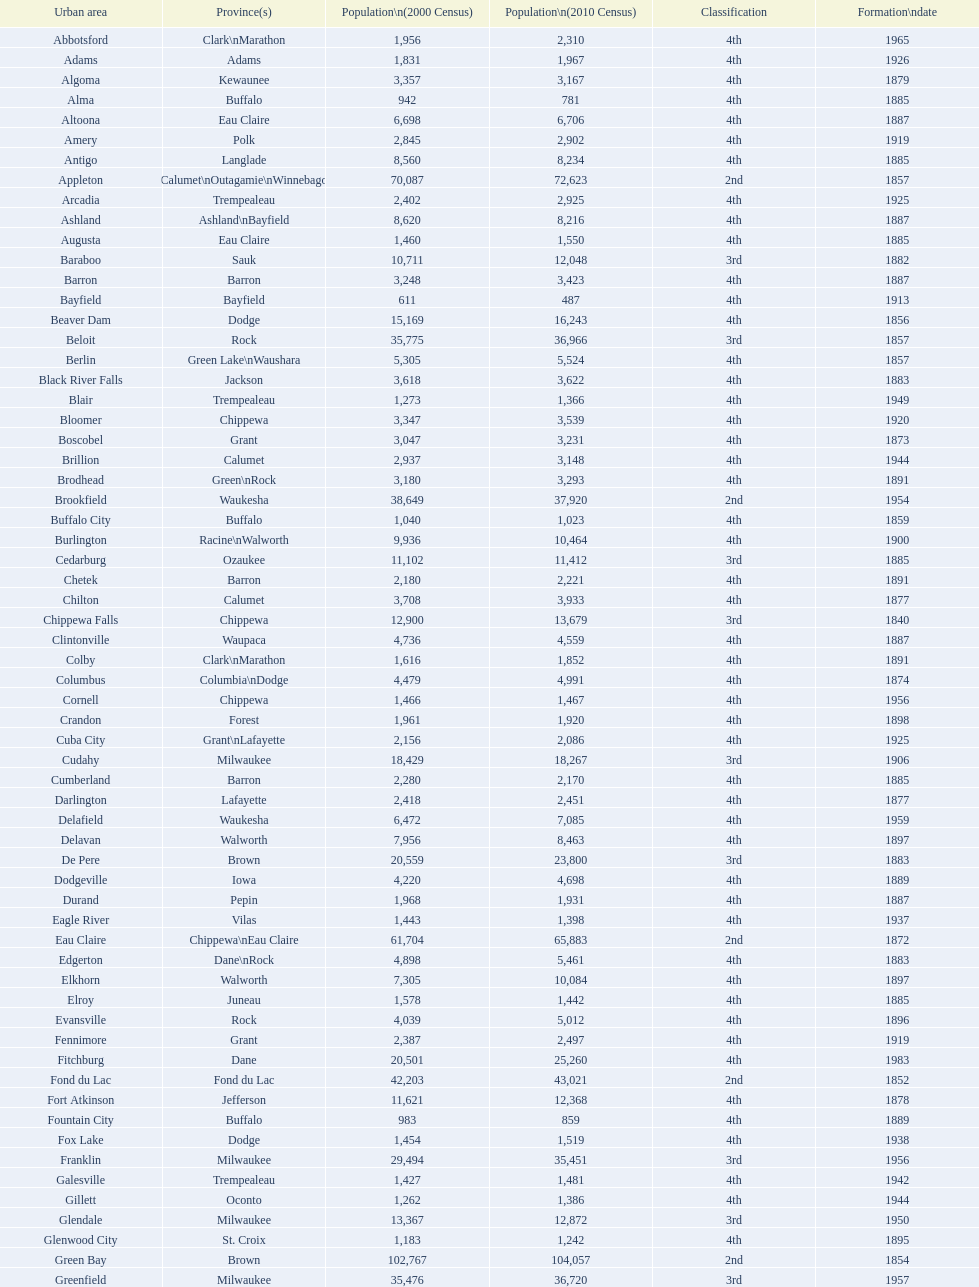Could you parse the entire table as a dict? {'header': ['Urban area', 'Province(s)', 'Population\\n(2000 Census)', 'Population\\n(2010 Census)', 'Classification', 'Formation\\ndate'], 'rows': [['Abbotsford', 'Clark\\nMarathon', '1,956', '2,310', '4th', '1965'], ['Adams', 'Adams', '1,831', '1,967', '4th', '1926'], ['Algoma', 'Kewaunee', '3,357', '3,167', '4th', '1879'], ['Alma', 'Buffalo', '942', '781', '4th', '1885'], ['Altoona', 'Eau Claire', '6,698', '6,706', '4th', '1887'], ['Amery', 'Polk', '2,845', '2,902', '4th', '1919'], ['Antigo', 'Langlade', '8,560', '8,234', '4th', '1885'], ['Appleton', 'Calumet\\nOutagamie\\nWinnebago', '70,087', '72,623', '2nd', '1857'], ['Arcadia', 'Trempealeau', '2,402', '2,925', '4th', '1925'], ['Ashland', 'Ashland\\nBayfield', '8,620', '8,216', '4th', '1887'], ['Augusta', 'Eau Claire', '1,460', '1,550', '4th', '1885'], ['Baraboo', 'Sauk', '10,711', '12,048', '3rd', '1882'], ['Barron', 'Barron', '3,248', '3,423', '4th', '1887'], ['Bayfield', 'Bayfield', '611', '487', '4th', '1913'], ['Beaver Dam', 'Dodge', '15,169', '16,243', '4th', '1856'], ['Beloit', 'Rock', '35,775', '36,966', '3rd', '1857'], ['Berlin', 'Green Lake\\nWaushara', '5,305', '5,524', '4th', '1857'], ['Black River Falls', 'Jackson', '3,618', '3,622', '4th', '1883'], ['Blair', 'Trempealeau', '1,273', '1,366', '4th', '1949'], ['Bloomer', 'Chippewa', '3,347', '3,539', '4th', '1920'], ['Boscobel', 'Grant', '3,047', '3,231', '4th', '1873'], ['Brillion', 'Calumet', '2,937', '3,148', '4th', '1944'], ['Brodhead', 'Green\\nRock', '3,180', '3,293', '4th', '1891'], ['Brookfield', 'Waukesha', '38,649', '37,920', '2nd', '1954'], ['Buffalo City', 'Buffalo', '1,040', '1,023', '4th', '1859'], ['Burlington', 'Racine\\nWalworth', '9,936', '10,464', '4th', '1900'], ['Cedarburg', 'Ozaukee', '11,102', '11,412', '3rd', '1885'], ['Chetek', 'Barron', '2,180', '2,221', '4th', '1891'], ['Chilton', 'Calumet', '3,708', '3,933', '4th', '1877'], ['Chippewa Falls', 'Chippewa', '12,900', '13,679', '3rd', '1840'], ['Clintonville', 'Waupaca', '4,736', '4,559', '4th', '1887'], ['Colby', 'Clark\\nMarathon', '1,616', '1,852', '4th', '1891'], ['Columbus', 'Columbia\\nDodge', '4,479', '4,991', '4th', '1874'], ['Cornell', 'Chippewa', '1,466', '1,467', '4th', '1956'], ['Crandon', 'Forest', '1,961', '1,920', '4th', '1898'], ['Cuba City', 'Grant\\nLafayette', '2,156', '2,086', '4th', '1925'], ['Cudahy', 'Milwaukee', '18,429', '18,267', '3rd', '1906'], ['Cumberland', 'Barron', '2,280', '2,170', '4th', '1885'], ['Darlington', 'Lafayette', '2,418', '2,451', '4th', '1877'], ['Delafield', 'Waukesha', '6,472', '7,085', '4th', '1959'], ['Delavan', 'Walworth', '7,956', '8,463', '4th', '1897'], ['De Pere', 'Brown', '20,559', '23,800', '3rd', '1883'], ['Dodgeville', 'Iowa', '4,220', '4,698', '4th', '1889'], ['Durand', 'Pepin', '1,968', '1,931', '4th', '1887'], ['Eagle River', 'Vilas', '1,443', '1,398', '4th', '1937'], ['Eau Claire', 'Chippewa\\nEau Claire', '61,704', '65,883', '2nd', '1872'], ['Edgerton', 'Dane\\nRock', '4,898', '5,461', '4th', '1883'], ['Elkhorn', 'Walworth', '7,305', '10,084', '4th', '1897'], ['Elroy', 'Juneau', '1,578', '1,442', '4th', '1885'], ['Evansville', 'Rock', '4,039', '5,012', '4th', '1896'], ['Fennimore', 'Grant', '2,387', '2,497', '4th', '1919'], ['Fitchburg', 'Dane', '20,501', '25,260', '4th', '1983'], ['Fond du Lac', 'Fond du Lac', '42,203', '43,021', '2nd', '1852'], ['Fort Atkinson', 'Jefferson', '11,621', '12,368', '4th', '1878'], ['Fountain City', 'Buffalo', '983', '859', '4th', '1889'], ['Fox Lake', 'Dodge', '1,454', '1,519', '4th', '1938'], ['Franklin', 'Milwaukee', '29,494', '35,451', '3rd', '1956'], ['Galesville', 'Trempealeau', '1,427', '1,481', '4th', '1942'], ['Gillett', 'Oconto', '1,262', '1,386', '4th', '1944'], ['Glendale', 'Milwaukee', '13,367', '12,872', '3rd', '1950'], ['Glenwood City', 'St. Croix', '1,183', '1,242', '4th', '1895'], ['Green Bay', 'Brown', '102,767', '104,057', '2nd', '1854'], ['Greenfield', 'Milwaukee', '35,476', '36,720', '3rd', '1957'], ['Green Lake', 'Green Lake', '1,100', '960', '4th', '1962'], ['Greenwood', 'Clark', '1,079', '1,026', '4th', '1891'], ['Hartford', 'Dodge\\nWashington', '10,905', '14,223', '3rd', '1883'], ['Hayward', 'Sawyer', '2,129', '2,318', '4th', '1915'], ['Hillsboro', 'Vernon', '1,302', '1,417', '4th', '1885'], ['Horicon', 'Dodge', '3,775', '3,655', '4th', '1897'], ['Hudson', 'St. Croix', '8,775', '12,719', '4th', '1858'], ['Hurley', 'Iron', '1,818', '1,547', '4th', '1918'], ['Independence', 'Trempealeau', '1,244', '1,336', '4th', '1942'], ['Janesville', 'Rock', '59,498', '63,575', '2nd', '1853'], ['Jefferson', 'Jefferson', '7,338', '7,973', '4th', '1878'], ['Juneau', 'Dodge', '2,485', '2,814', '4th', '1887'], ['Kaukauna', 'Outagamie', '12,983', '15,462', '3rd', '1885'], ['Kenosha', 'Kenosha', '90,352', '99,218', '2nd', '1850'], ['Kewaunee', 'Kewaunee', '2,806', '2,952', '4th', '1883'], ['Kiel', 'Calumet\\nManitowoc', '3,450', '3,738', '4th', '1920'], ['La Crosse', 'La Crosse', '51,818', '51,320', '2nd', '1856'], ['Ladysmith', 'Rusk', '3,932', '3,414', '4th', '1905'], ['Lake Geneva', 'Walworth', '7,148', '7,651', '4th', '1883'], ['Lake Mills', 'Jefferson', '4,843', '5,708', '4th', '1905'], ['Lancaster', 'Grant', '4,070', '3,868', '4th', '1878'], ['Lodi', 'Columbia', '2,882', '3,050', '4th', '1941'], ['Loyal', 'Clark', '1,308', '1,261', '4th', '1948'], ['Madison', 'Dane', '208,054', '233,209', '2nd', '1856'], ['Manawa', 'Waupaca', '1,330', '1,371', '4th', '1954'], ['Manitowoc', 'Manitowoc', '34,053', '33,736', '3rd', '1870'], ['Marinette', 'Marinette', '11,749', '10,968', '3rd', '1887'], ['Marion', 'Shawano\\nWaupaca', '1,297', '1,260', '4th', '1898'], ['Markesan', 'Green Lake', '1,396', '1,476', '4th', '1959'], ['Marshfield', 'Marathon\\nWood', '18,800', '19,118', '3rd', '1883'], ['Mauston', 'Juneau', '3,740', '4,423', '4th', '1883'], ['Mayville', 'Dodge', '4,902', '5,154', '4th', '1885'], ['Medford', 'Taylor', '4,350', '4,326', '4th', '1889'], ['Mellen', 'Ashland', '845', '731', '4th', '1907'], ['Menasha', 'Calumet\\nWinnebago', '16,331', '17,353', '3rd', '1874'], ['Menomonie', 'Dunn', '14,937', '16,264', '4th', '1882'], ['Mequon', 'Ozaukee', '22,643', '23,132', '4th', '1957'], ['Merrill', 'Lincoln', '10,146', '9,661', '4th', '1883'], ['Middleton', 'Dane', '15,770', '17,442', '3rd', '1963'], ['Milton', 'Rock', '5,132', '5,546', '4th', '1969'], ['Milwaukee', 'Milwaukee\\nWashington\\nWaukesha', '596,974', '594,833', '1st', '1846'], ['Mineral Point', 'Iowa', '2,617', '2,487', '4th', '1857'], ['Mondovi', 'Buffalo', '2,634', '2,777', '4th', '1889'], ['Monona', 'Dane', '8,018', '7,533', '4th', '1969'], ['Monroe', 'Green', '10,843', '10,827', '4th', '1882'], ['Montello', 'Marquette', '1,397', '1,495', '4th', '1938'], ['Montreal', 'Iron', '838', '807', '4th', '1924'], ['Mosinee', 'Marathon', '4,063', '3,988', '4th', '1931'], ['Muskego', 'Waukesha', '21,397', '24,135', '3rd', '1964'], ['Neenah', 'Winnebago', '24,507', '25,501', '3rd', '1873'], ['Neillsville', 'Clark', '2,731', '2,463', '4th', '1882'], ['Nekoosa', 'Wood', '2,590', '2,580', '4th', '1926'], ['New Berlin', 'Waukesha', '38,220', '39,584', '3rd', '1959'], ['New Holstein', 'Calumet', '3,301', '3,236', '4th', '1889'], ['New Lisbon', 'Juneau', '1,436', '2,554', '4th', '1889'], ['New London', 'Outagamie\\nWaupaca', '7,085', '7,295', '4th', '1877'], ['New Richmond', 'St. Croix', '6,310', '8,375', '4th', '1885'], ['Niagara', 'Marinette', '1,880', '1,624', '4th', '1992'], ['Oak Creek', 'Milwaukee', '28,456', '34,451', '3rd', '1955'], ['Oconomowoc', 'Waukesha', '12,382', '15,712', '3rd', '1875'], ['Oconto', 'Oconto', '4,708', '4,513', '4th', '1869'], ['Oconto Falls', 'Oconto', '2,843', '2,891', '4th', '1919'], ['Omro', 'Winnebago', '3,177', '3,517', '4th', '1944'], ['Onalaska', 'La Crosse', '14,839', '17,736', '4th', '1887'], ['Oshkosh', 'Winnebago', '62,916', '66,083', '2nd', '1853'], ['Osseo', 'Trempealeau', '1,669', '1,701', '4th', '1941'], ['Owen', 'Clark', '936', '940', '4th', '1925'], ['Park Falls', 'Price', '2,739', '2,462', '4th', '1912'], ['Peshtigo', 'Marinette', '3,474', '3,502', '4th', '1903'], ['Pewaukee', 'Waukesha', '11,783', '13,195', '3rd', '1999'], ['Phillips', 'Price', '1,675', '1,478', '4th', '1891'], ['Pittsville', 'Wood', '866', '874', '4th', '1887'], ['Platteville', 'Grant', '9,989', '11,224', '4th', '1876'], ['Plymouth', 'Sheboygan', '7,781', '8,445', '4th', '1877'], ['Port Washington', 'Ozaukee', '10,467', '11,250', '4th', '1882'], ['Portage', 'Columbia', '9,728', '10,324', '4th', '1854'], ['Prairie du Chien', 'Crawford', '6,018', '5,911', '4th', '1872'], ['Prescott', 'Pierce', '3,764', '4,258', '4th', '1857'], ['Princeton', 'Green Lake', '1,504', '1,214', '4th', '1920'], ['Racine', 'Racine', '81,855', '78,860', '2nd', '1848'], ['Reedsburg', 'Sauk', '7,827', '10,014', '4th', '1887'], ['Rhinelander', 'Oneida', '7,735', '7,798', '4th', '1894'], ['Rice Lake', 'Barron', '8,312', '8,438', '4th', '1887'], ['Richland Center', 'Richland', '5,114', '5,184', '4th', '1887'], ['Ripon', 'Fond du Lac', '7,450', '7,733', '4th', '1858'], ['River Falls', 'Pierce\\nSt. Croix', '12,560', '15,000', '3rd', '1875'], ['St. Croix Falls', 'Polk', '2,033', '2,133', '4th', '1958'], ['St. Francis', 'Milwaukee', '8,662', '9,365', '4th', '1951'], ['Schofield', 'Marathon', '2,117', '2,169', '4th', '1951'], ['Seymour', 'Outagamie', '3,335', '3,451', '4th', '1879'], ['Shawano', 'Shawano', '8,298', '9,305', '4th', '1874'], ['Sheboygan', 'Sheboygan', '50,792', '49,288', '2nd', '1853'], ['Sheboygan Falls', 'Sheboygan', '6,772', '7,775', '4th', '1913'], ['Shell Lake', 'Washburn', '1,309', '1,347', '4th', '1961'], ['Shullsburg', 'Lafayette', '1,246', '1,226', '4th', '1889'], ['South Milwaukee', 'Milwaukee', '21,256', '21,156', '4th', '1897'], ['Sparta', 'Monroe', '8,648', '9,522', '4th', '1883'], ['Spooner', 'Washburn', '2,653', '2,682', '4th', '1909'], ['Stanley', 'Chippewa\\nClark', '1,898', '3,608', '4th', '1898'], ['Stevens Point', 'Portage', '24,551', '26,717', '3rd', '1858'], ['Stoughton', 'Dane', '12,354', '12,611', '4th', '1882'], ['Sturgeon Bay', 'Door', '9,437', '9,144', '4th', '1883'], ['Sun Prairie', 'Dane', '20,369', '29,364', '3rd', '1958'], ['Superior', 'Douglas', '27,368', '27,244', '2nd', '1858'], ['Thorp', 'Clark', '1,536', '1,621', '4th', '1948'], ['Tomah', 'Monroe', '8,419', '9,093', '4th', '1883'], ['Tomahawk', 'Lincoln', '3,770', '3,397', '4th', '1891'], ['Two Rivers', 'Manitowoc', '12,639', '11,712', '3rd', '1878'], ['Verona', 'Dane', '7,052', '10,619', '4th', '1977'], ['Viroqua', 'Vernon', '4,335', '5,079', '4th', '1885'], ['Washburn', 'Bayfield', '2,280', '2,117', '4th', '1904'], ['Waterloo', 'Jefferson', '3,259', '3,333', '4th', '1962'], ['Watertown', 'Dodge\\nJefferson', '21,598', '23,861', '3rd', '1853'], ['Waukesha', 'Waukesha', '64,825', '70,718', '2nd', '1895'], ['Waupaca', 'Waupaca', '5,676', '6,069', '4th', '1878'], ['Waupun', 'Dodge\\nFond du Lac', '10,944', '11,340', '4th', '1878'], ['Wausau', 'Marathon', '38,426', '39,106', '3rd', '1872'], ['Wautoma', 'Waushara', '1,998', '2,218', '4th', '1901'], ['Wauwatosa', 'Milwaukee', '47,271', '46,396', '2nd', '1897'], ['West Allis', 'Milwaukee', '61,254', '60,411', '2nd', '1906'], ['West Bend', 'Washington', '28,152', '31,078', '3rd', '1885'], ['Westby', 'Vernon', '2,045', '2,200', '4th', '1920'], ['Weyauwega', 'Waupaca', '1,806', '1,900', '4th', '1939'], ['Whitehall', 'Trempealeau', '1,651', '1,558', '4th', '1941'], ['Whitewater', 'Jefferson\\nWalworth', '13,437', '14,390', '4th', '1885'], ['Wisconsin Dells', 'Adams\\nColumbia\\nJuneau\\nSauk', '2,418', '2,678', '4th', '1925'], ['Wisconsin Rapids', 'Wood', '18,435', '18,367', '3rd', '1869']]} Which city in wisconsin is the most populous, based on the 2010 census? Milwaukee. 